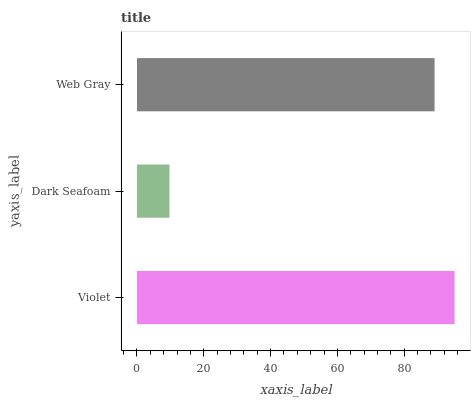Is Dark Seafoam the minimum?
Answer yes or no. Yes. Is Violet the maximum?
Answer yes or no. Yes. Is Web Gray the minimum?
Answer yes or no. No. Is Web Gray the maximum?
Answer yes or no. No. Is Web Gray greater than Dark Seafoam?
Answer yes or no. Yes. Is Dark Seafoam less than Web Gray?
Answer yes or no. Yes. Is Dark Seafoam greater than Web Gray?
Answer yes or no. No. Is Web Gray less than Dark Seafoam?
Answer yes or no. No. Is Web Gray the high median?
Answer yes or no. Yes. Is Web Gray the low median?
Answer yes or no. Yes. Is Violet the high median?
Answer yes or no. No. Is Dark Seafoam the low median?
Answer yes or no. No. 